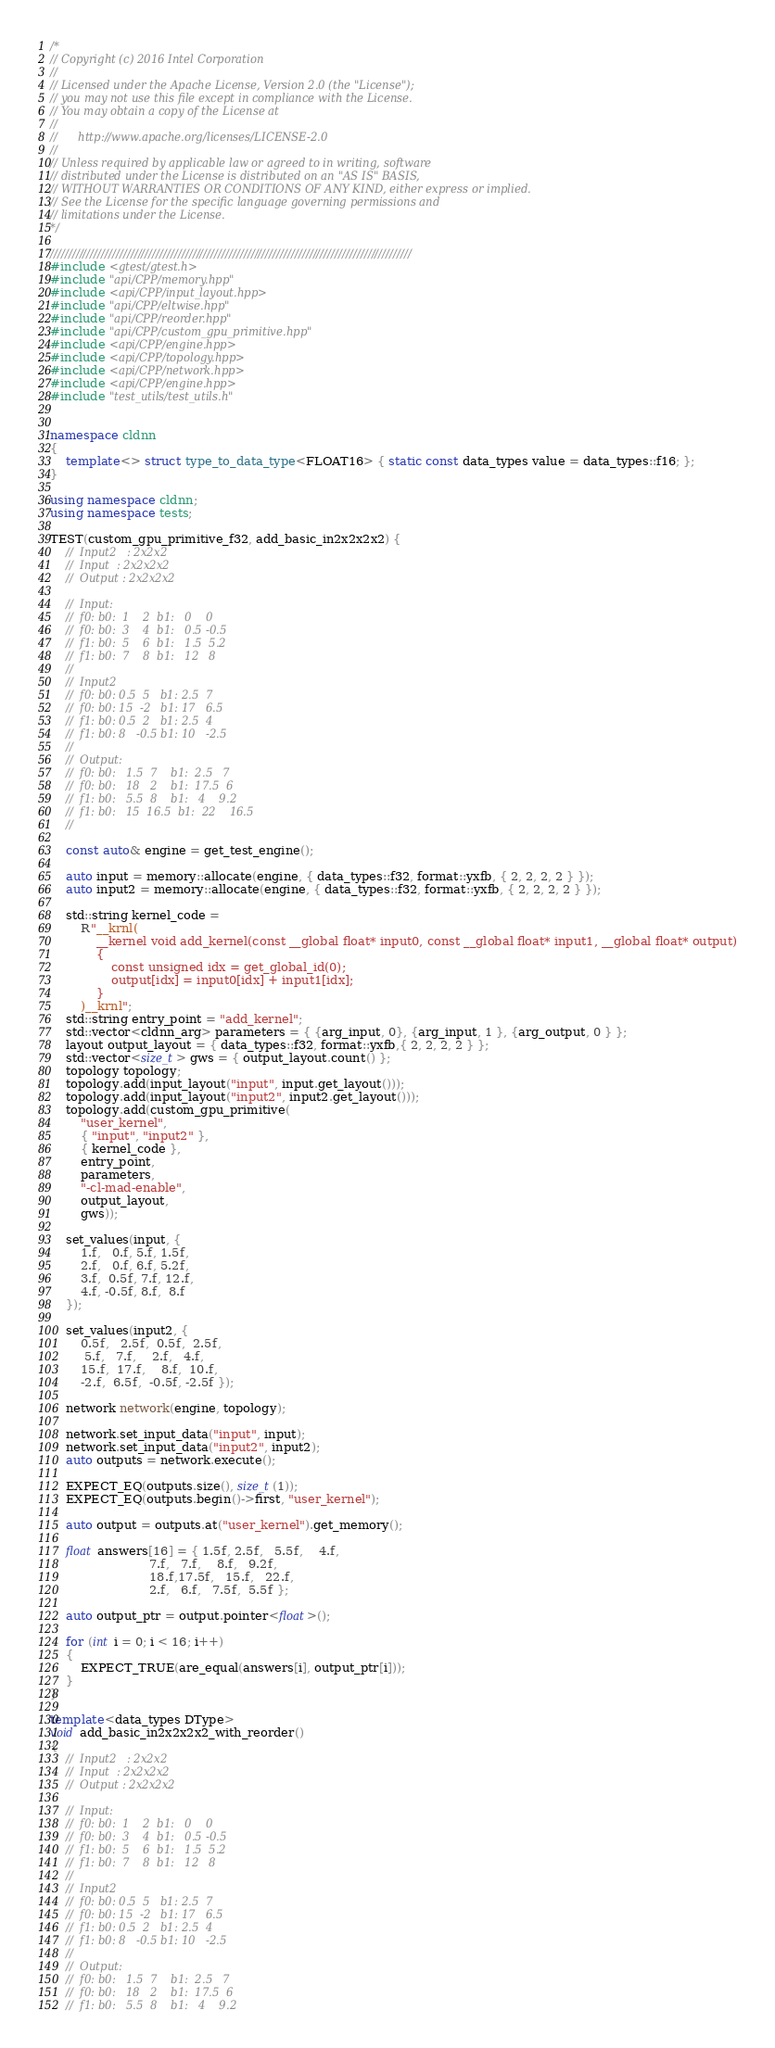Convert code to text. <code><loc_0><loc_0><loc_500><loc_500><_C++_>/*
// Copyright (c) 2016 Intel Corporation
//
// Licensed under the Apache License, Version 2.0 (the "License");
// you may not use this file except in compliance with the License.
// You may obtain a copy of the License at
//
//      http://www.apache.org/licenses/LICENSE-2.0
//
// Unless required by applicable law or agreed to in writing, software
// distributed under the License is distributed on an "AS IS" BASIS,
// WITHOUT WARRANTIES OR CONDITIONS OF ANY KIND, either express or implied.
// See the License for the specific language governing permissions and
// limitations under the License.
*/

///////////////////////////////////////////////////////////////////////////////////////////////////
#include <gtest/gtest.h>
#include "api/CPP/memory.hpp"
#include <api/CPP/input_layout.hpp>
#include "api/CPP/eltwise.hpp"
#include "api/CPP/reorder.hpp"
#include "api/CPP/custom_gpu_primitive.hpp"
#include <api/CPP/engine.hpp>
#include <api/CPP/topology.hpp>
#include <api/CPP/network.hpp>
#include <api/CPP/engine.hpp>
#include "test_utils/test_utils.h"


namespace cldnn
{
	template<> struct type_to_data_type<FLOAT16> { static const data_types value = data_types::f16; };
}

using namespace cldnn;
using namespace tests;

TEST(custom_gpu_primitive_f32, add_basic_in2x2x2x2) {
    //  Input2   : 2x2x2
    //  Input  : 2x2x2x2
    //  Output : 2x2x2x2

    //  Input:
    //  f0: b0:  1    2  b1:   0    0       
    //  f0: b0:  3    4  b1:   0.5 -0.5     
    //  f1: b0:  5    6  b1:   1.5  5.2     
    //  f1: b0:  7    8  b1:   12   8       
    //
    //  Input2
    //  f0: b0: 0.5  5   b1: 2.5  7 
    //  f0: b0: 15  -2   b1: 17   6.5
    //  f1: b0: 0.5  2   b1: 2.5  4
    //  f1: b0: 8   -0.5 b1: 10   -2.5
    //
    //  Output:
    //  f0: b0:   1.5  7    b1:  2.5   7      
    //  f0: b0:   18   2    b1:  17.5  6     
    //  f1: b0:   5.5  8    b1:   4    9.2     
    //  f1: b0:   15  16.5  b1:  22    16.5     
    //

    const auto& engine = get_test_engine();

    auto input = memory::allocate(engine, { data_types::f32, format::yxfb, { 2, 2, 2, 2 } });
    auto input2 = memory::allocate(engine, { data_types::f32, format::yxfb, { 2, 2, 2, 2 } });

    std::string kernel_code =
        R"__krnl(
            __kernel void add_kernel(const __global float* input0, const __global float* input1, __global float* output)
            {
                const unsigned idx = get_global_id(0);
                output[idx] = input0[idx] + input1[idx];
            }
        )__krnl";
    std::string entry_point = "add_kernel";
    std::vector<cldnn_arg> parameters = { {arg_input, 0}, {arg_input, 1 }, {arg_output, 0 } };
    layout output_layout = { data_types::f32, format::yxfb,{ 2, 2, 2, 2 } };
    std::vector<size_t> gws = { output_layout.count() };
    topology topology;
    topology.add(input_layout("input", input.get_layout()));
    topology.add(input_layout("input2", input2.get_layout()));
    topology.add(custom_gpu_primitive(
        "user_kernel", 
        { "input", "input2" },
        { kernel_code },
        entry_point,
        parameters,
        "-cl-mad-enable",
        output_layout,
        gws));

    set_values(input, {
        1.f,   0.f, 5.f, 1.5f,
        2.f,   0.f, 6.f, 5.2f,
        3.f,  0.5f, 7.f, 12.f,
        4.f, -0.5f, 8.f,  8.f
    });

    set_values(input2, {
        0.5f,   2.5f,  0.5f,  2.5f,
         5.f,   7.f,    2.f,   4.f,
        15.f,  17.f,    8.f,  10.f,
        -2.f,  6.5f,  -0.5f, -2.5f });

    network network(engine, topology);

    network.set_input_data("input", input);
    network.set_input_data("input2", input2);
    auto outputs = network.execute();

    EXPECT_EQ(outputs.size(), size_t(1));
    EXPECT_EQ(outputs.begin()->first, "user_kernel");

    auto output = outputs.at("user_kernel").get_memory();

    float answers[16] = { 1.5f, 2.5f,   5.5f,    4.f,
                          7.f,   7.f,    8.f,   9.2f,
                          18.f,17.5f,   15.f,   22.f,
                          2.f,   6.f,   7.5f,  5.5f };

    auto output_ptr = output.pointer<float>();

    for (int i = 0; i < 16; i++)
    {
        EXPECT_TRUE(are_equal(answers[i], output_ptr[i]));
    }
}

template<data_types DType>
void add_basic_in2x2x2x2_with_reorder()
{
    //  Input2   : 2x2x2
    //  Input  : 2x2x2x2
    //  Output : 2x2x2x2

    //  Input:
    //  f0: b0:  1    2  b1:   0    0       
    //  f0: b0:  3    4  b1:   0.5 -0.5     
    //  f1: b0:  5    6  b1:   1.5  5.2     
    //  f1: b0:  7    8  b1:   12   8       
    //
    //  Input2
    //  f0: b0: 0.5  5   b1: 2.5  7 
    //  f0: b0: 15  -2   b1: 17   6.5
    //  f1: b0: 0.5  2   b1: 2.5  4
    //  f1: b0: 8   -0.5 b1: 10   -2.5
    //
    //  Output:
    //  f0: b0:   1.5  7    b1:  2.5   7      
    //  f0: b0:   18   2    b1:  17.5  6     
    //  f1: b0:   5.5  8    b1:   4    9.2     </code> 